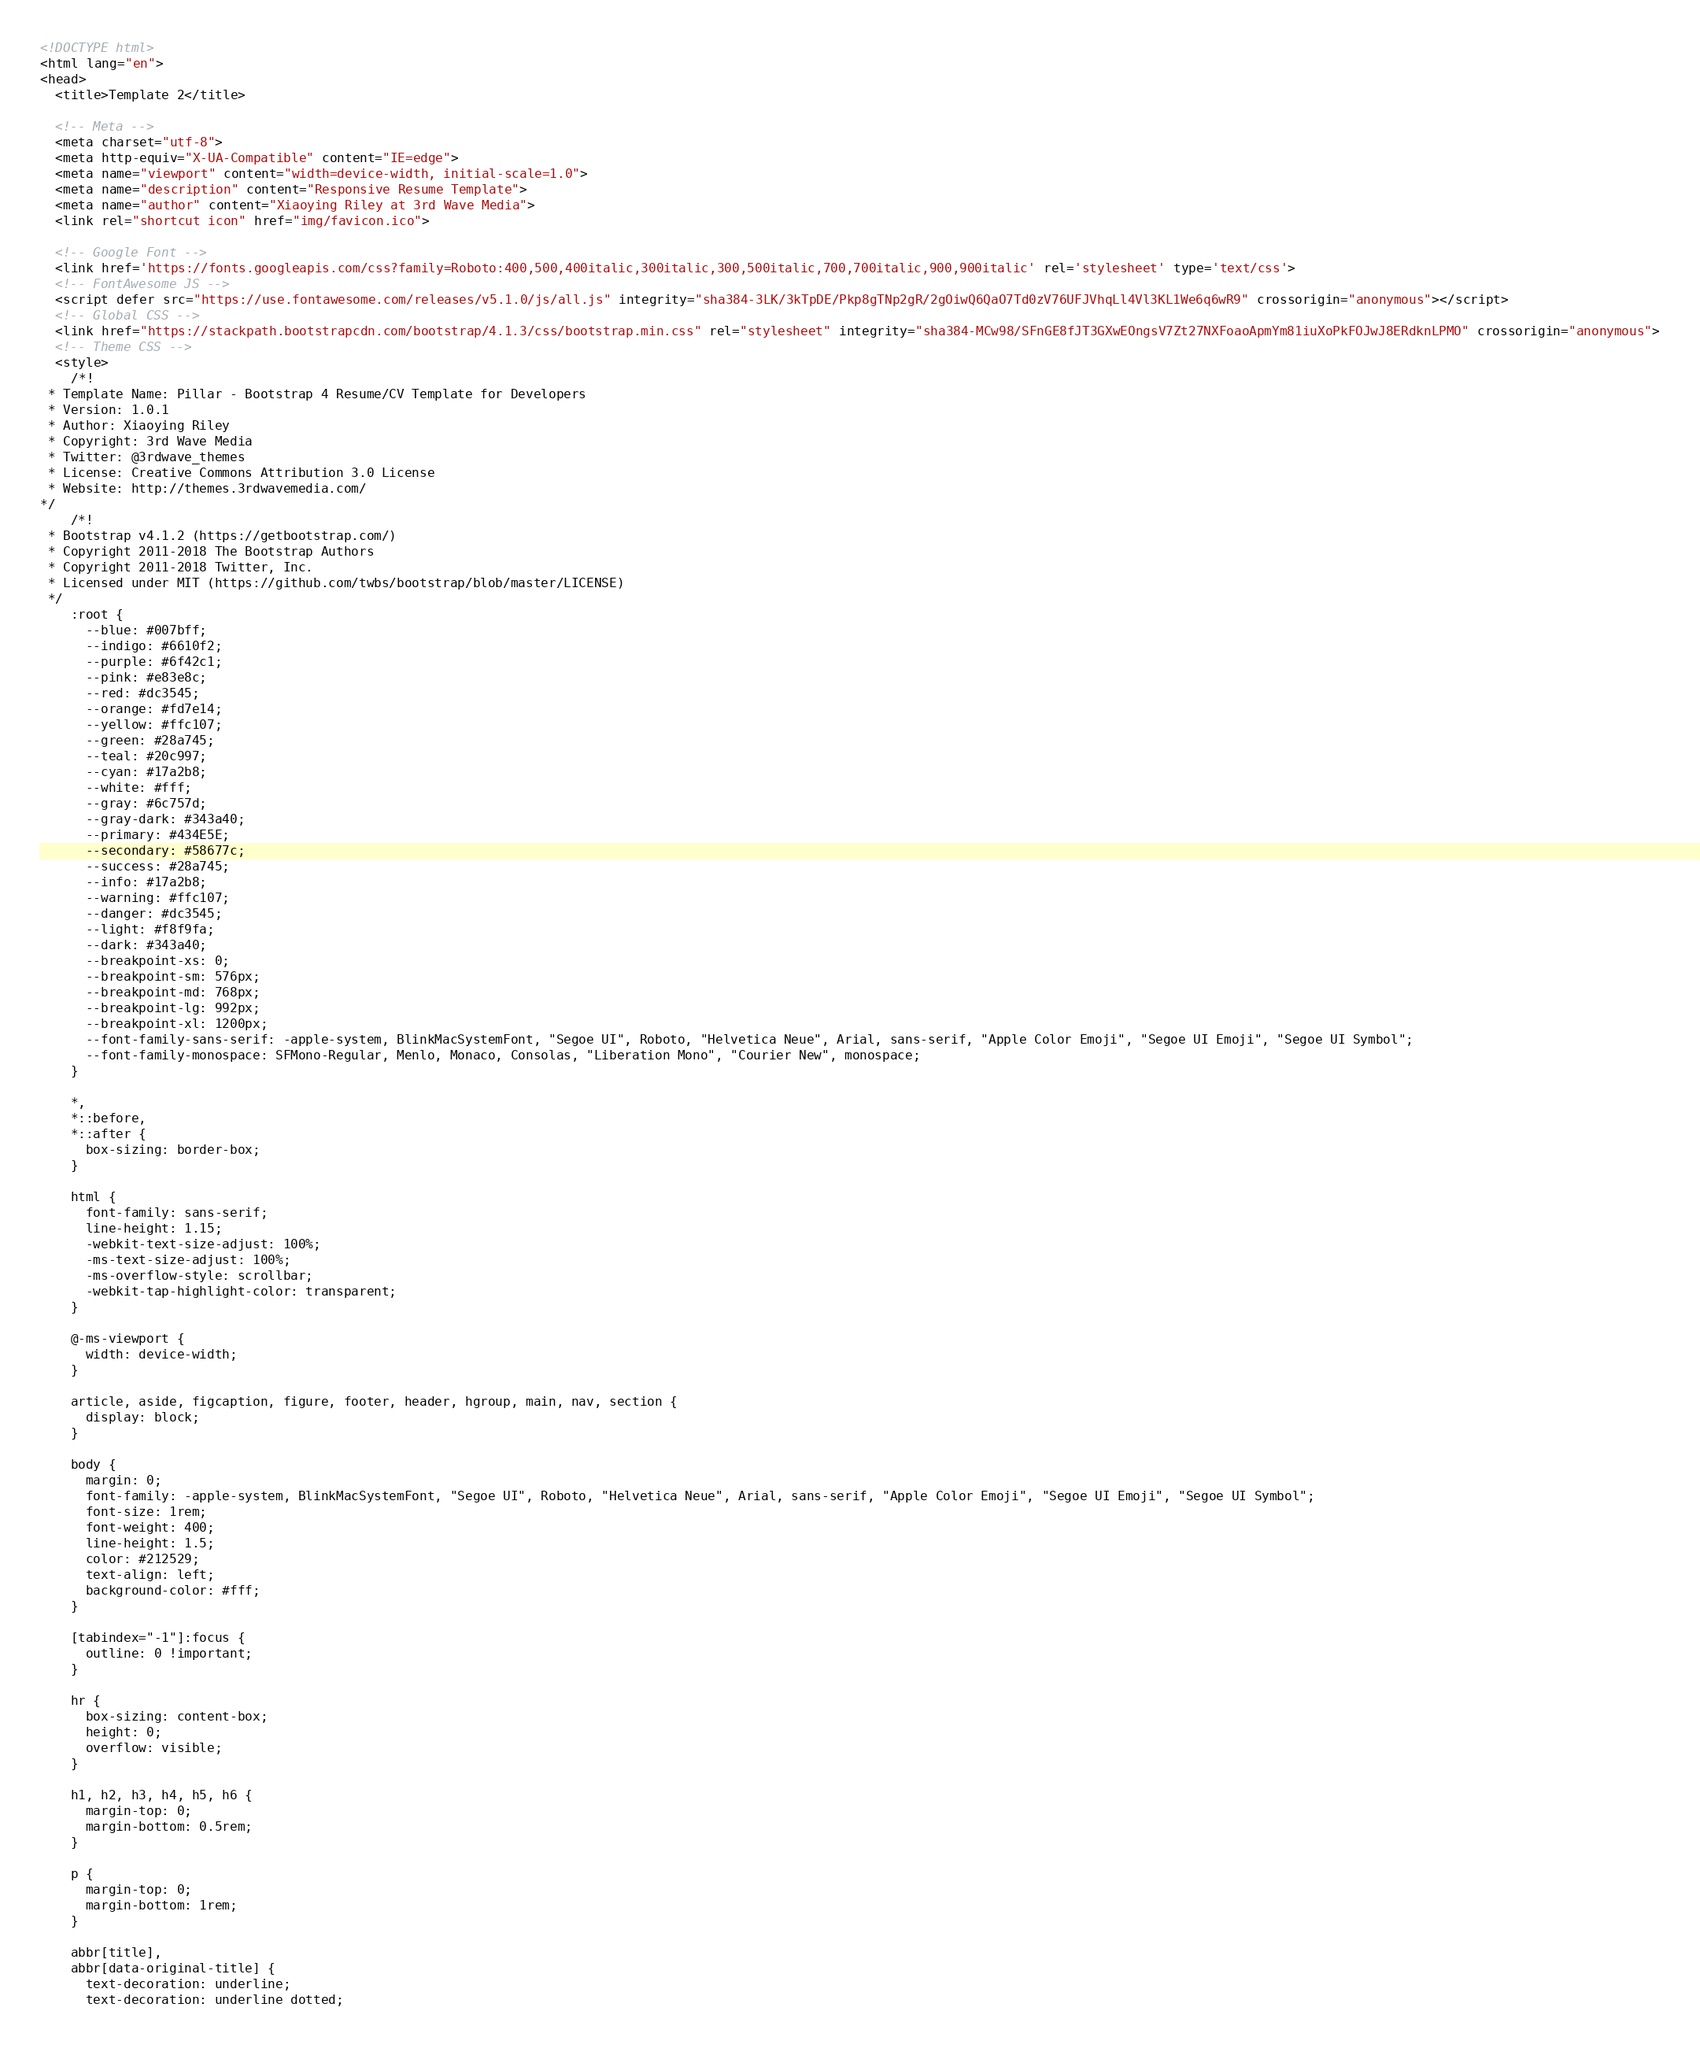<code> <loc_0><loc_0><loc_500><loc_500><_HTML_>
<!DOCTYPE html>
<html lang="en">
<head>
  <title>Template 2</title>

  <!-- Meta -->
  <meta charset="utf-8">
  <meta http-equiv="X-UA-Compatible" content="IE=edge">
  <meta name="viewport" content="width=device-width, initial-scale=1.0">
  <meta name="description" content="Responsive Resume Template">
  <meta name="author" content="Xiaoying Riley at 3rd Wave Media">
  <link rel="shortcut icon" href="img/favicon.ico">

  <!-- Google Font -->
  <link href='https://fonts.googleapis.com/css?family=Roboto:400,500,400italic,300italic,300,500italic,700,700italic,900,900italic' rel='stylesheet' type='text/css'>
  <!-- FontAwesome JS -->
  <script defer src="https://use.fontawesome.com/releases/v5.1.0/js/all.js" integrity="sha384-3LK/3kTpDE/Pkp8gTNp2gR/2gOiwQ6QaO7Td0zV76UFJVhqLl4Vl3KL1We6q6wR9" crossorigin="anonymous"></script>
  <!-- Global CSS -->
  <link href="https://stackpath.bootstrapcdn.com/bootstrap/4.1.3/css/bootstrap.min.css" rel="stylesheet" integrity="sha384-MCw98/SFnGE8fJT3GXwEOngsV7Zt27NXFoaoApmYm81iuXoPkFOJwJ8ERdknLPMO" crossorigin="anonymous">
  <!-- Theme CSS -->
  <style>
    /*!
 * Template Name: Pillar - Bootstrap 4 Resume/CV Template for Developers
 * Version: 1.0.1
 * Author: Xiaoying Riley
 * Copyright: 3rd Wave Media
 * Twitter: @3rdwave_themes
 * License: Creative Commons Attribution 3.0 License
 * Website: http://themes.3rdwavemedia.com/
*/
    /*!
 * Bootstrap v4.1.2 (https://getbootstrap.com/)
 * Copyright 2011-2018 The Bootstrap Authors
 * Copyright 2011-2018 Twitter, Inc.
 * Licensed under MIT (https://github.com/twbs/bootstrap/blob/master/LICENSE)
 */
    :root {
      --blue: #007bff;
      --indigo: #6610f2;
      --purple: #6f42c1;
      --pink: #e83e8c;
      --red: #dc3545;
      --orange: #fd7e14;
      --yellow: #ffc107;
      --green: #28a745;
      --teal: #20c997;
      --cyan: #17a2b8;
      --white: #fff;
      --gray: #6c757d;
      --gray-dark: #343a40;
      --primary: #434E5E;
      --secondary: #58677c;
      --success: #28a745;
      --info: #17a2b8;
      --warning: #ffc107;
      --danger: #dc3545;
      --light: #f8f9fa;
      --dark: #343a40;
      --breakpoint-xs: 0;
      --breakpoint-sm: 576px;
      --breakpoint-md: 768px;
      --breakpoint-lg: 992px;
      --breakpoint-xl: 1200px;
      --font-family-sans-serif: -apple-system, BlinkMacSystemFont, "Segoe UI", Roboto, "Helvetica Neue", Arial, sans-serif, "Apple Color Emoji", "Segoe UI Emoji", "Segoe UI Symbol";
      --font-family-monospace: SFMono-Regular, Menlo, Monaco, Consolas, "Liberation Mono", "Courier New", monospace;
    }

    *,
    *::before,
    *::after {
      box-sizing: border-box;
    }

    html {
      font-family: sans-serif;
      line-height: 1.15;
      -webkit-text-size-adjust: 100%;
      -ms-text-size-adjust: 100%;
      -ms-overflow-style: scrollbar;
      -webkit-tap-highlight-color: transparent;
    }

    @-ms-viewport {
      width: device-width;
    }

    article, aside, figcaption, figure, footer, header, hgroup, main, nav, section {
      display: block;
    }

    body {
      margin: 0;
      font-family: -apple-system, BlinkMacSystemFont, "Segoe UI", Roboto, "Helvetica Neue", Arial, sans-serif, "Apple Color Emoji", "Segoe UI Emoji", "Segoe UI Symbol";
      font-size: 1rem;
      font-weight: 400;
      line-height: 1.5;
      color: #212529;
      text-align: left;
      background-color: #fff;
    }

    [tabindex="-1"]:focus {
      outline: 0 !important;
    }

    hr {
      box-sizing: content-box;
      height: 0;
      overflow: visible;
    }

    h1, h2, h3, h4, h5, h6 {
      margin-top: 0;
      margin-bottom: 0.5rem;
    }

    p {
      margin-top: 0;
      margin-bottom: 1rem;
    }

    abbr[title],
    abbr[data-original-title] {
      text-decoration: underline;
      text-decoration: underline dotted;</code> 